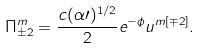<formula> <loc_0><loc_0><loc_500><loc_500>\Pi ^ { m } _ { \pm 2 } = { \frac { c ( \alpha \prime ) ^ { 1 / 2 } } { 2 } } e ^ { - \phi } u ^ { m [ \mp 2 ] } .</formula> 